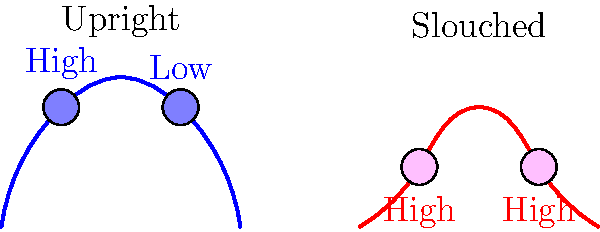Based on the cross-sectional diagrams of the human spine in upright and slouched postures, how does the stress distribution differ between these two positions? Explain the biomechanical implications for long-term spinal health. To analyze the stress distribution in the human spine during upright and slouched postures, we need to consider the following steps:

1. Upright posture (blue curve):
   - The spine maintains its natural S-curve.
   - Stress is more evenly distributed along the vertebrae.
   - Upper section shows higher stress due to the weight of the head.
   - Lower section shows lower stress as the spine efficiently transfers load to the pelvis.

2. Slouched posture (red curve):
   - The natural S-curve is flattened or reversed.
   - Stress is concentrated in both the upper and lower sections of the spine.
   - This uneven distribution leads to higher overall stress on the vertebrae and intervertebral discs.

3. Biomechanical implications:
   - In the upright posture, the spine's natural curve acts as a shock absorber, distributing forces more evenly.
   - The slouched posture increases the load on specific areas, potentially leading to:
     a) Increased pressure on intervertebral discs
     b) Higher risk of disc herniation
     c) Strain on supporting muscles and ligaments
     d) Potential for chronic back pain and degenerative conditions

4. Long-term spinal health:
   - Maintaining good posture (upright) helps preserve the spine's natural curve and promotes even stress distribution.
   - Prolonged slouching can lead to adaptive shortening of anterior spinal ligaments and weakening of supporting muscles.
   - Over time, this may result in a permanent alteration of spinal curvature and increased risk of spinal disorders.

5. Biomechanical principle:
   The stress ($\sigma$) on a spinal segment can be approximated by the equation:
   
   $$\sigma = \frac{F}{A} + \frac{Mc}{I}$$
   
   Where $F$ is the axial force, $A$ is the cross-sectional area, $M$ is the bending moment, $c$ is the distance from the neutral axis, and $I$ is the moment of inertia.

In the slouched posture, the increased bending moment ($M$) leads to higher stress concentrations in certain areas of the spine.
Answer: Upright posture distributes stress more evenly, while slouched posture concentrates stress in upper and lower spine, increasing risk of long-term spinal problems. 